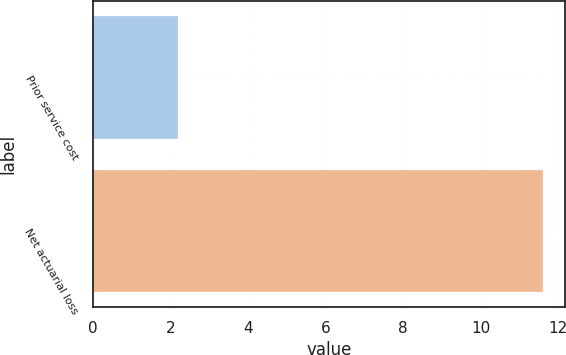Convert chart. <chart><loc_0><loc_0><loc_500><loc_500><bar_chart><fcel>Prior service cost<fcel>Net actuarial loss<nl><fcel>2.2<fcel>11.6<nl></chart> 